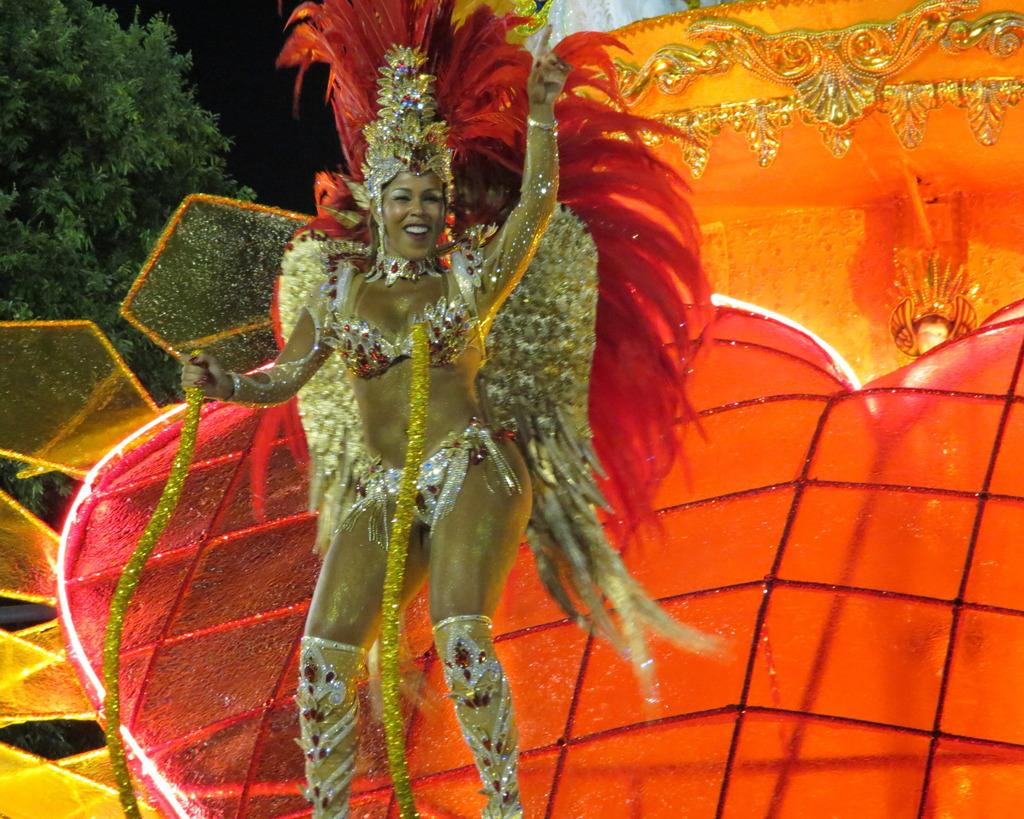Who is present in the image? There is a woman in the image. What is the woman doing in the image? The woman is standing and smiling. What can be seen in the background of the image? There is a light and decorative things in the background of the image. What is located on the left side of the image? There is a tree on the left side of the image. What type of punishment is the woman receiving in the image? There is no indication in the image that the woman is receiving any punishment; she is standing and smiling. 